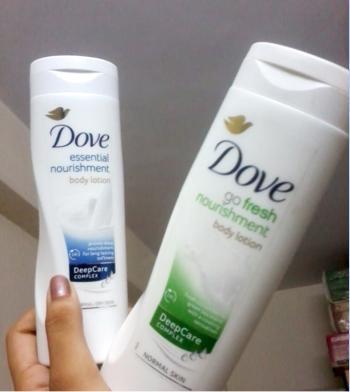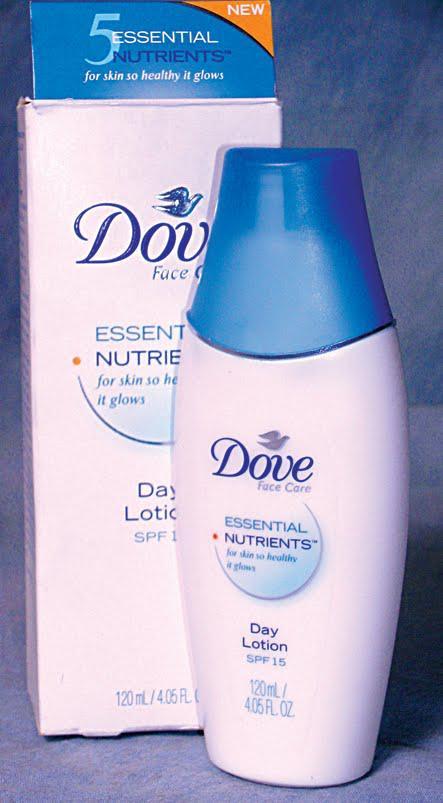The first image is the image on the left, the second image is the image on the right. Assess this claim about the two images: "There is at least one product shown with its corresponding box.". Correct or not? Answer yes or no. Yes. The first image is the image on the left, the second image is the image on the right. For the images shown, is this caption "The left image shows two containers labeled, """"Dove.""""" true? Answer yes or no. Yes. 